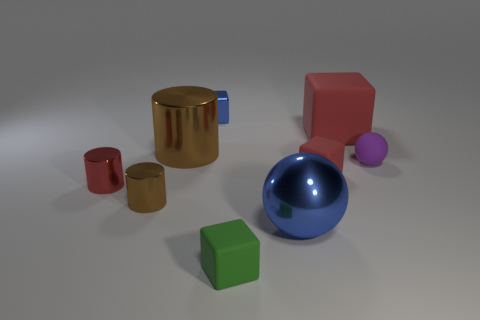There is a small blue thing that is the same shape as the green object; what is its material?
Ensure brevity in your answer.  Metal. Are there any large shiny things to the left of the tiny purple rubber ball that is behind the red metallic cylinder that is left of the tiny red block?
Provide a short and direct response. Yes. Do the small red object that is right of the big shiny cylinder and the big metal object that is to the left of the blue sphere have the same shape?
Provide a short and direct response. No. Are there more metallic objects that are in front of the large red rubber cube than large matte things?
Offer a very short reply. Yes. How many things are large yellow blocks or small objects?
Your answer should be very brief. 6. What color is the large metal ball?
Ensure brevity in your answer.  Blue. How many other objects are there of the same color as the small matte sphere?
Your response must be concise. 0. There is a small red metallic object; are there any spheres behind it?
Your answer should be compact. Yes. The cube that is in front of the red thing that is on the left side of the small rubber thing that is to the left of the large sphere is what color?
Make the answer very short. Green. What number of small things are both in front of the large blue shiny ball and to the left of the big metallic cylinder?
Ensure brevity in your answer.  0. 